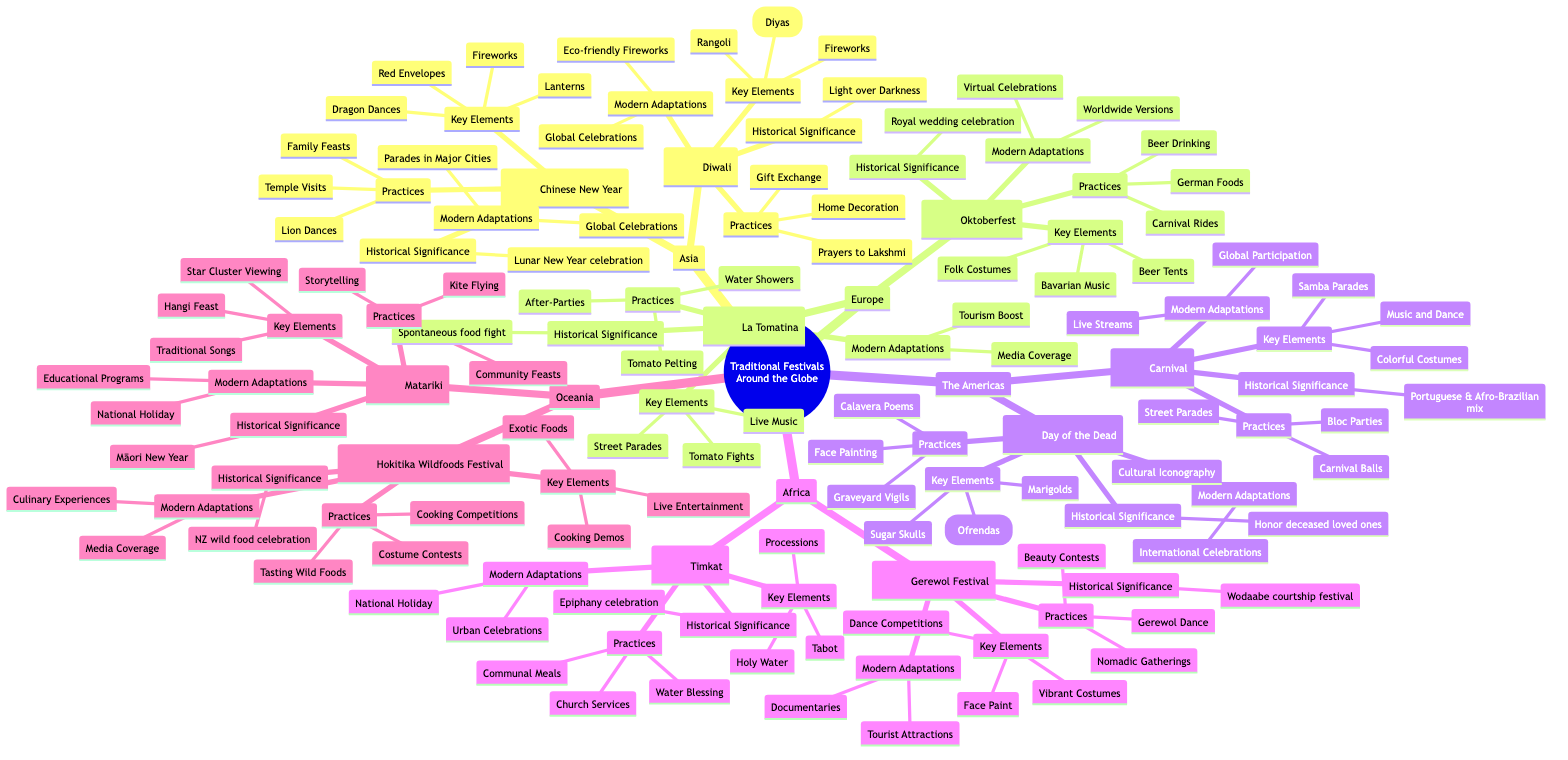What are the key elements of Diwali? The diagram lists three key elements for Diwali: Oil Lamps (Diyas), Fireworks, and Rangoli. These elements are under the "Key Elements" node for Diwali.
Answer: Oil Lamps (Diyas), Fireworks, Rangoli How many festivals are there in Africa? In the Africa section of the diagram, there are two festivals listed: Timkat and Gerewol Festival. By counting these, we determine the total number of festivals in Africa.
Answer: 2 What is the historical significance of the Carnival in Brazil? The historical significance of the Carnival is described as a mix of Portuguese and Afro-Brazilian traditions, celebrating before Lent. This information can be found under the "Historical Significance" node for Carnival.
Answer: Portuguese & Afro-Brazilian mix Which festival includes Tomato Fights as a key element? The festival that includes Tomato Fights is La Tomatina, as identified in the "Key Elements" section specifically for this festival within the Europe category.
Answer: La Tomatina What modern adaptations are shared by both Chinese New Year and Diwali? Both festivals share the modern adaptations of Global Celebrations and have adapted the ways in which they are celebrated internationally. This can be found under the "Modern Adaptations" nodes for each festival.
Answer: Global Celebrations What is an activity practiced during Timkat? One of the activities practiced during Timkat is the Water Blessing, as listed under the "Practices" for this festival.
Answer: Water Blessing How many elements are listed under the key elements of Oktoberfest? The key elements for Oktoberfest include Beer Tents, Traditional Bavarian Music, and Folk Costumes, totaling three elements, which can be directly counted from the "Key Elements" section.
Answer: 3 What type of performances are part of the Gerewol Festival? The Gerewol Festival includes Dance Competitions as a significant type of performance, which is specifically listed under the "Practices" for this festival within the Africa section.
Answer: Dance Competitions What unique feature is associated with Matariki? Matariki is uniquely associated with the Star Cluster Viewing, which is indicated as one of the key elements under the Matariki festival node in the Oceania section.
Answer: Star Cluster Viewing 